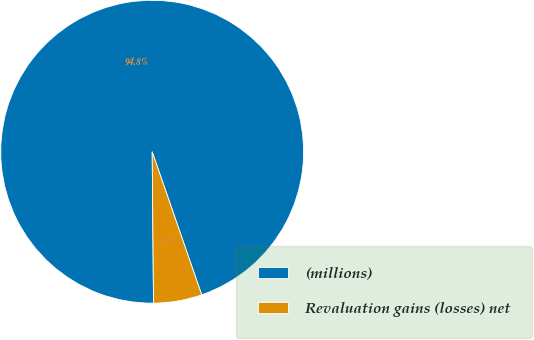<chart> <loc_0><loc_0><loc_500><loc_500><pie_chart><fcel>(millions)<fcel>Revaluation gains (losses) net<nl><fcel>94.84%<fcel>5.16%<nl></chart> 